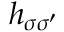<formula> <loc_0><loc_0><loc_500><loc_500>h _ { \sigma \sigma ^ { \prime } }</formula> 